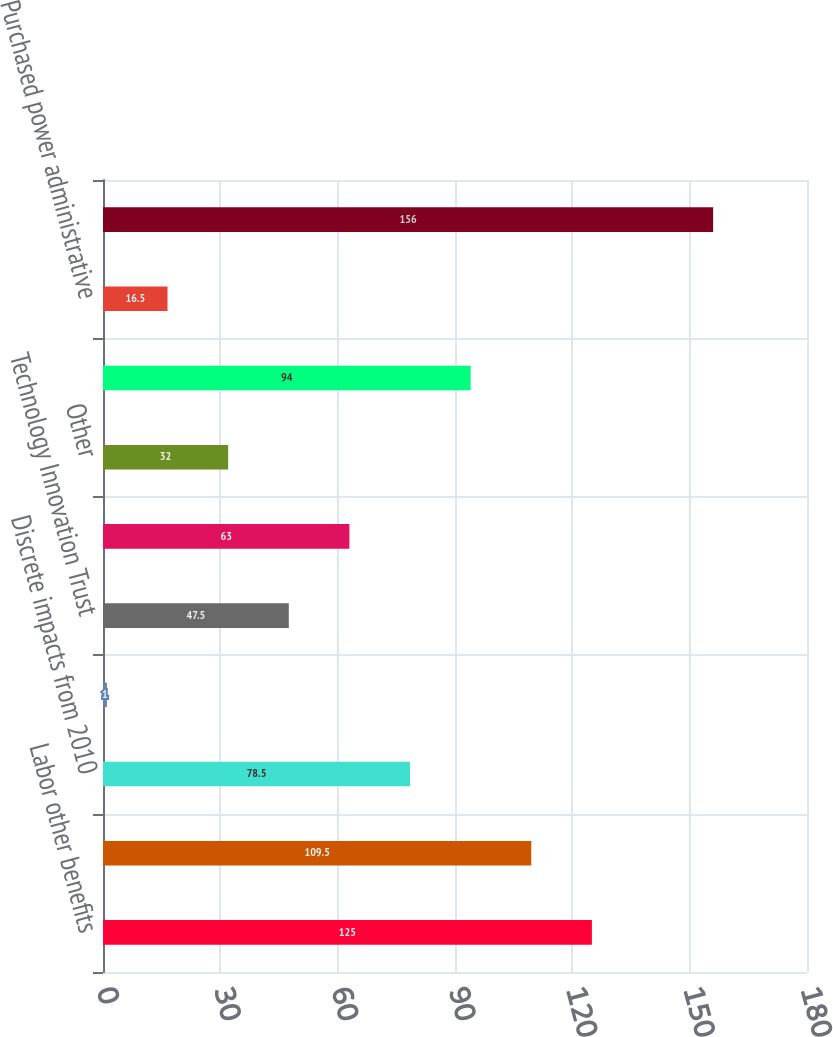<chart> <loc_0><loc_0><loc_500><loc_500><bar_chart><fcel>Labor other benefits<fcel>Pension and non-pension<fcel>Discrete impacts from 2010<fcel>Storm Related Costs (d)<fcel>Technology Innovation Trust<fcel>Uncollectible accounts expense<fcel>Other<fcel>Energy efficiency and demand<fcel>Purchased power administrative<fcel>Increase in operating and<nl><fcel>125<fcel>109.5<fcel>78.5<fcel>1<fcel>47.5<fcel>63<fcel>32<fcel>94<fcel>16.5<fcel>156<nl></chart> 